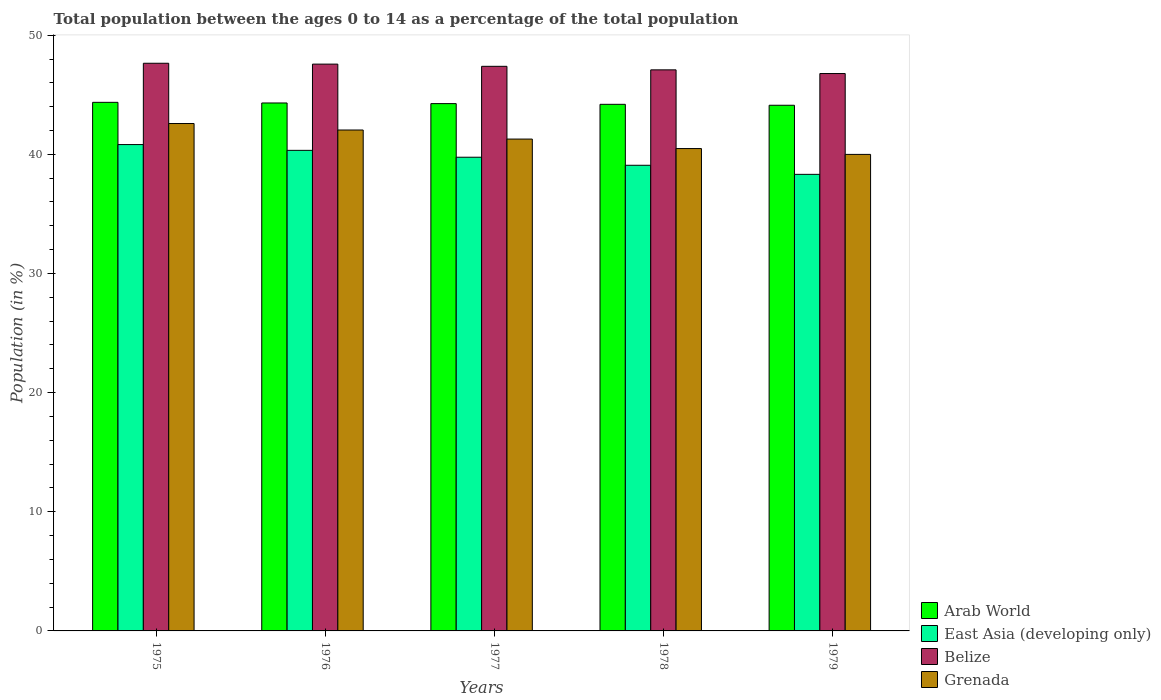Are the number of bars per tick equal to the number of legend labels?
Offer a very short reply. Yes. Are the number of bars on each tick of the X-axis equal?
Your response must be concise. Yes. How many bars are there on the 5th tick from the left?
Ensure brevity in your answer.  4. What is the label of the 1st group of bars from the left?
Offer a terse response. 1975. In how many cases, is the number of bars for a given year not equal to the number of legend labels?
Provide a short and direct response. 0. What is the percentage of the population ages 0 to 14 in Grenada in 1979?
Provide a succinct answer. 39.99. Across all years, what is the maximum percentage of the population ages 0 to 14 in East Asia (developing only)?
Give a very brief answer. 40.82. Across all years, what is the minimum percentage of the population ages 0 to 14 in Arab World?
Give a very brief answer. 44.12. In which year was the percentage of the population ages 0 to 14 in Belize maximum?
Your answer should be compact. 1975. In which year was the percentage of the population ages 0 to 14 in East Asia (developing only) minimum?
Make the answer very short. 1979. What is the total percentage of the population ages 0 to 14 in East Asia (developing only) in the graph?
Your answer should be very brief. 198.31. What is the difference between the percentage of the population ages 0 to 14 in Grenada in 1975 and that in 1979?
Your answer should be compact. 2.59. What is the difference between the percentage of the population ages 0 to 14 in East Asia (developing only) in 1975 and the percentage of the population ages 0 to 14 in Arab World in 1976?
Provide a succinct answer. -3.49. What is the average percentage of the population ages 0 to 14 in Grenada per year?
Provide a succinct answer. 41.28. In the year 1977, what is the difference between the percentage of the population ages 0 to 14 in Belize and percentage of the population ages 0 to 14 in East Asia (developing only)?
Provide a short and direct response. 7.63. In how many years, is the percentage of the population ages 0 to 14 in Belize greater than 46?
Provide a succinct answer. 5. What is the ratio of the percentage of the population ages 0 to 14 in Arab World in 1975 to that in 1977?
Your answer should be compact. 1. Is the difference between the percentage of the population ages 0 to 14 in Belize in 1976 and 1978 greater than the difference between the percentage of the population ages 0 to 14 in East Asia (developing only) in 1976 and 1978?
Your answer should be compact. No. What is the difference between the highest and the second highest percentage of the population ages 0 to 14 in Belize?
Your response must be concise. 0.07. What is the difference between the highest and the lowest percentage of the population ages 0 to 14 in East Asia (developing only)?
Make the answer very short. 2.5. What does the 2nd bar from the left in 1979 represents?
Your answer should be compact. East Asia (developing only). What does the 4th bar from the right in 1975 represents?
Provide a short and direct response. Arab World. Is it the case that in every year, the sum of the percentage of the population ages 0 to 14 in Belize and percentage of the population ages 0 to 14 in Grenada is greater than the percentage of the population ages 0 to 14 in East Asia (developing only)?
Keep it short and to the point. Yes. How many years are there in the graph?
Offer a very short reply. 5. What is the difference between two consecutive major ticks on the Y-axis?
Ensure brevity in your answer.  10. Are the values on the major ticks of Y-axis written in scientific E-notation?
Your answer should be very brief. No. Does the graph contain any zero values?
Keep it short and to the point. No. What is the title of the graph?
Give a very brief answer. Total population between the ages 0 to 14 as a percentage of the total population. What is the label or title of the X-axis?
Your answer should be very brief. Years. What is the label or title of the Y-axis?
Your answer should be very brief. Population (in %). What is the Population (in %) in Arab World in 1975?
Make the answer very short. 44.36. What is the Population (in %) of East Asia (developing only) in 1975?
Offer a terse response. 40.82. What is the Population (in %) of Belize in 1975?
Your answer should be very brief. 47.64. What is the Population (in %) of Grenada in 1975?
Your answer should be compact. 42.59. What is the Population (in %) in Arab World in 1976?
Make the answer very short. 44.31. What is the Population (in %) in East Asia (developing only) in 1976?
Ensure brevity in your answer.  40.33. What is the Population (in %) in Belize in 1976?
Provide a succinct answer. 47.57. What is the Population (in %) of Grenada in 1976?
Provide a short and direct response. 42.04. What is the Population (in %) in Arab World in 1977?
Your answer should be very brief. 44.26. What is the Population (in %) of East Asia (developing only) in 1977?
Your answer should be compact. 39.76. What is the Population (in %) in Belize in 1977?
Your answer should be compact. 47.39. What is the Population (in %) of Grenada in 1977?
Your response must be concise. 41.28. What is the Population (in %) of Arab World in 1978?
Keep it short and to the point. 44.2. What is the Population (in %) in East Asia (developing only) in 1978?
Give a very brief answer. 39.08. What is the Population (in %) of Belize in 1978?
Offer a terse response. 47.09. What is the Population (in %) in Grenada in 1978?
Give a very brief answer. 40.48. What is the Population (in %) in Arab World in 1979?
Offer a terse response. 44.12. What is the Population (in %) of East Asia (developing only) in 1979?
Offer a very short reply. 38.32. What is the Population (in %) of Belize in 1979?
Your answer should be compact. 46.78. What is the Population (in %) of Grenada in 1979?
Your answer should be compact. 39.99. Across all years, what is the maximum Population (in %) of Arab World?
Offer a very short reply. 44.36. Across all years, what is the maximum Population (in %) of East Asia (developing only)?
Give a very brief answer. 40.82. Across all years, what is the maximum Population (in %) of Belize?
Keep it short and to the point. 47.64. Across all years, what is the maximum Population (in %) of Grenada?
Make the answer very short. 42.59. Across all years, what is the minimum Population (in %) of Arab World?
Give a very brief answer. 44.12. Across all years, what is the minimum Population (in %) in East Asia (developing only)?
Offer a terse response. 38.32. Across all years, what is the minimum Population (in %) of Belize?
Provide a short and direct response. 46.78. Across all years, what is the minimum Population (in %) of Grenada?
Provide a short and direct response. 39.99. What is the total Population (in %) of Arab World in the graph?
Your answer should be very brief. 221.24. What is the total Population (in %) of East Asia (developing only) in the graph?
Your answer should be very brief. 198.31. What is the total Population (in %) of Belize in the graph?
Provide a short and direct response. 236.47. What is the total Population (in %) in Grenada in the graph?
Offer a terse response. 206.39. What is the difference between the Population (in %) of Arab World in 1975 and that in 1976?
Offer a terse response. 0.05. What is the difference between the Population (in %) of East Asia (developing only) in 1975 and that in 1976?
Your response must be concise. 0.48. What is the difference between the Population (in %) of Belize in 1975 and that in 1976?
Your response must be concise. 0.07. What is the difference between the Population (in %) in Grenada in 1975 and that in 1976?
Offer a terse response. 0.55. What is the difference between the Population (in %) in Arab World in 1975 and that in 1977?
Offer a terse response. 0.11. What is the difference between the Population (in %) of East Asia (developing only) in 1975 and that in 1977?
Provide a succinct answer. 1.06. What is the difference between the Population (in %) in Belize in 1975 and that in 1977?
Give a very brief answer. 0.26. What is the difference between the Population (in %) of Grenada in 1975 and that in 1977?
Your answer should be compact. 1.31. What is the difference between the Population (in %) in Arab World in 1975 and that in 1978?
Provide a succinct answer. 0.17. What is the difference between the Population (in %) of East Asia (developing only) in 1975 and that in 1978?
Offer a very short reply. 1.74. What is the difference between the Population (in %) of Belize in 1975 and that in 1978?
Provide a short and direct response. 0.55. What is the difference between the Population (in %) in Grenada in 1975 and that in 1978?
Provide a short and direct response. 2.1. What is the difference between the Population (in %) of Arab World in 1975 and that in 1979?
Give a very brief answer. 0.24. What is the difference between the Population (in %) of East Asia (developing only) in 1975 and that in 1979?
Your answer should be compact. 2.5. What is the difference between the Population (in %) of Belize in 1975 and that in 1979?
Offer a very short reply. 0.86. What is the difference between the Population (in %) of Grenada in 1975 and that in 1979?
Provide a succinct answer. 2.59. What is the difference between the Population (in %) of Arab World in 1976 and that in 1977?
Your answer should be very brief. 0.05. What is the difference between the Population (in %) of East Asia (developing only) in 1976 and that in 1977?
Your answer should be very brief. 0.58. What is the difference between the Population (in %) in Belize in 1976 and that in 1977?
Ensure brevity in your answer.  0.18. What is the difference between the Population (in %) in Grenada in 1976 and that in 1977?
Offer a terse response. 0.76. What is the difference between the Population (in %) in Arab World in 1976 and that in 1978?
Keep it short and to the point. 0.11. What is the difference between the Population (in %) of East Asia (developing only) in 1976 and that in 1978?
Your answer should be compact. 1.25. What is the difference between the Population (in %) of Belize in 1976 and that in 1978?
Give a very brief answer. 0.48. What is the difference between the Population (in %) in Grenada in 1976 and that in 1978?
Provide a succinct answer. 1.56. What is the difference between the Population (in %) in Arab World in 1976 and that in 1979?
Your response must be concise. 0.19. What is the difference between the Population (in %) of East Asia (developing only) in 1976 and that in 1979?
Offer a very short reply. 2.01. What is the difference between the Population (in %) in Belize in 1976 and that in 1979?
Give a very brief answer. 0.79. What is the difference between the Population (in %) of Grenada in 1976 and that in 1979?
Provide a succinct answer. 2.05. What is the difference between the Population (in %) in Arab World in 1977 and that in 1978?
Keep it short and to the point. 0.06. What is the difference between the Population (in %) in East Asia (developing only) in 1977 and that in 1978?
Give a very brief answer. 0.68. What is the difference between the Population (in %) in Belize in 1977 and that in 1978?
Make the answer very short. 0.3. What is the difference between the Population (in %) in Grenada in 1977 and that in 1978?
Your answer should be very brief. 0.8. What is the difference between the Population (in %) in Arab World in 1977 and that in 1979?
Ensure brevity in your answer.  0.14. What is the difference between the Population (in %) in East Asia (developing only) in 1977 and that in 1979?
Give a very brief answer. 1.44. What is the difference between the Population (in %) in Belize in 1977 and that in 1979?
Your answer should be very brief. 0.61. What is the difference between the Population (in %) in Grenada in 1977 and that in 1979?
Offer a terse response. 1.29. What is the difference between the Population (in %) in Arab World in 1978 and that in 1979?
Keep it short and to the point. 0.08. What is the difference between the Population (in %) of East Asia (developing only) in 1978 and that in 1979?
Provide a succinct answer. 0.76. What is the difference between the Population (in %) in Belize in 1978 and that in 1979?
Provide a short and direct response. 0.31. What is the difference between the Population (in %) of Grenada in 1978 and that in 1979?
Provide a short and direct response. 0.49. What is the difference between the Population (in %) in Arab World in 1975 and the Population (in %) in East Asia (developing only) in 1976?
Your answer should be compact. 4.03. What is the difference between the Population (in %) of Arab World in 1975 and the Population (in %) of Belize in 1976?
Offer a very short reply. -3.21. What is the difference between the Population (in %) in Arab World in 1975 and the Population (in %) in Grenada in 1976?
Give a very brief answer. 2.32. What is the difference between the Population (in %) of East Asia (developing only) in 1975 and the Population (in %) of Belize in 1976?
Make the answer very short. -6.75. What is the difference between the Population (in %) in East Asia (developing only) in 1975 and the Population (in %) in Grenada in 1976?
Ensure brevity in your answer.  -1.22. What is the difference between the Population (in %) in Belize in 1975 and the Population (in %) in Grenada in 1976?
Your response must be concise. 5.6. What is the difference between the Population (in %) in Arab World in 1975 and the Population (in %) in East Asia (developing only) in 1977?
Your response must be concise. 4.61. What is the difference between the Population (in %) of Arab World in 1975 and the Population (in %) of Belize in 1977?
Offer a very short reply. -3.02. What is the difference between the Population (in %) in Arab World in 1975 and the Population (in %) in Grenada in 1977?
Offer a terse response. 3.08. What is the difference between the Population (in %) of East Asia (developing only) in 1975 and the Population (in %) of Belize in 1977?
Your response must be concise. -6.57. What is the difference between the Population (in %) in East Asia (developing only) in 1975 and the Population (in %) in Grenada in 1977?
Your answer should be very brief. -0.46. What is the difference between the Population (in %) in Belize in 1975 and the Population (in %) in Grenada in 1977?
Make the answer very short. 6.36. What is the difference between the Population (in %) of Arab World in 1975 and the Population (in %) of East Asia (developing only) in 1978?
Your answer should be compact. 5.28. What is the difference between the Population (in %) of Arab World in 1975 and the Population (in %) of Belize in 1978?
Provide a succinct answer. -2.73. What is the difference between the Population (in %) of Arab World in 1975 and the Population (in %) of Grenada in 1978?
Your answer should be very brief. 3.88. What is the difference between the Population (in %) in East Asia (developing only) in 1975 and the Population (in %) in Belize in 1978?
Offer a terse response. -6.27. What is the difference between the Population (in %) of East Asia (developing only) in 1975 and the Population (in %) of Grenada in 1978?
Offer a terse response. 0.34. What is the difference between the Population (in %) in Belize in 1975 and the Population (in %) in Grenada in 1978?
Your answer should be very brief. 7.16. What is the difference between the Population (in %) of Arab World in 1975 and the Population (in %) of East Asia (developing only) in 1979?
Your response must be concise. 6.04. What is the difference between the Population (in %) in Arab World in 1975 and the Population (in %) in Belize in 1979?
Your answer should be very brief. -2.42. What is the difference between the Population (in %) of Arab World in 1975 and the Population (in %) of Grenada in 1979?
Provide a succinct answer. 4.37. What is the difference between the Population (in %) of East Asia (developing only) in 1975 and the Population (in %) of Belize in 1979?
Your answer should be very brief. -5.96. What is the difference between the Population (in %) of East Asia (developing only) in 1975 and the Population (in %) of Grenada in 1979?
Your answer should be compact. 0.83. What is the difference between the Population (in %) in Belize in 1975 and the Population (in %) in Grenada in 1979?
Offer a terse response. 7.65. What is the difference between the Population (in %) in Arab World in 1976 and the Population (in %) in East Asia (developing only) in 1977?
Your answer should be very brief. 4.55. What is the difference between the Population (in %) in Arab World in 1976 and the Population (in %) in Belize in 1977?
Your answer should be compact. -3.08. What is the difference between the Population (in %) in Arab World in 1976 and the Population (in %) in Grenada in 1977?
Give a very brief answer. 3.03. What is the difference between the Population (in %) of East Asia (developing only) in 1976 and the Population (in %) of Belize in 1977?
Offer a very short reply. -7.05. What is the difference between the Population (in %) of East Asia (developing only) in 1976 and the Population (in %) of Grenada in 1977?
Your response must be concise. -0.95. What is the difference between the Population (in %) in Belize in 1976 and the Population (in %) in Grenada in 1977?
Offer a very short reply. 6.29. What is the difference between the Population (in %) in Arab World in 1976 and the Population (in %) in East Asia (developing only) in 1978?
Offer a terse response. 5.23. What is the difference between the Population (in %) in Arab World in 1976 and the Population (in %) in Belize in 1978?
Your response must be concise. -2.78. What is the difference between the Population (in %) in Arab World in 1976 and the Population (in %) in Grenada in 1978?
Ensure brevity in your answer.  3.83. What is the difference between the Population (in %) in East Asia (developing only) in 1976 and the Population (in %) in Belize in 1978?
Offer a terse response. -6.76. What is the difference between the Population (in %) of East Asia (developing only) in 1976 and the Population (in %) of Grenada in 1978?
Ensure brevity in your answer.  -0.15. What is the difference between the Population (in %) in Belize in 1976 and the Population (in %) in Grenada in 1978?
Ensure brevity in your answer.  7.09. What is the difference between the Population (in %) of Arab World in 1976 and the Population (in %) of East Asia (developing only) in 1979?
Ensure brevity in your answer.  5.99. What is the difference between the Population (in %) in Arab World in 1976 and the Population (in %) in Belize in 1979?
Ensure brevity in your answer.  -2.47. What is the difference between the Population (in %) of Arab World in 1976 and the Population (in %) of Grenada in 1979?
Your response must be concise. 4.32. What is the difference between the Population (in %) in East Asia (developing only) in 1976 and the Population (in %) in Belize in 1979?
Your answer should be very brief. -6.45. What is the difference between the Population (in %) of East Asia (developing only) in 1976 and the Population (in %) of Grenada in 1979?
Provide a short and direct response. 0.34. What is the difference between the Population (in %) in Belize in 1976 and the Population (in %) in Grenada in 1979?
Keep it short and to the point. 7.58. What is the difference between the Population (in %) of Arab World in 1977 and the Population (in %) of East Asia (developing only) in 1978?
Offer a very short reply. 5.17. What is the difference between the Population (in %) of Arab World in 1977 and the Population (in %) of Belize in 1978?
Your answer should be very brief. -2.83. What is the difference between the Population (in %) of Arab World in 1977 and the Population (in %) of Grenada in 1978?
Ensure brevity in your answer.  3.77. What is the difference between the Population (in %) in East Asia (developing only) in 1977 and the Population (in %) in Belize in 1978?
Give a very brief answer. -7.33. What is the difference between the Population (in %) of East Asia (developing only) in 1977 and the Population (in %) of Grenada in 1978?
Ensure brevity in your answer.  -0.73. What is the difference between the Population (in %) in Belize in 1977 and the Population (in %) in Grenada in 1978?
Offer a very short reply. 6.9. What is the difference between the Population (in %) of Arab World in 1977 and the Population (in %) of East Asia (developing only) in 1979?
Your answer should be compact. 5.94. What is the difference between the Population (in %) of Arab World in 1977 and the Population (in %) of Belize in 1979?
Provide a succinct answer. -2.53. What is the difference between the Population (in %) in Arab World in 1977 and the Population (in %) in Grenada in 1979?
Your response must be concise. 4.26. What is the difference between the Population (in %) of East Asia (developing only) in 1977 and the Population (in %) of Belize in 1979?
Provide a succinct answer. -7.02. What is the difference between the Population (in %) of East Asia (developing only) in 1977 and the Population (in %) of Grenada in 1979?
Provide a short and direct response. -0.24. What is the difference between the Population (in %) in Belize in 1977 and the Population (in %) in Grenada in 1979?
Give a very brief answer. 7.39. What is the difference between the Population (in %) of Arab World in 1978 and the Population (in %) of East Asia (developing only) in 1979?
Offer a very short reply. 5.88. What is the difference between the Population (in %) of Arab World in 1978 and the Population (in %) of Belize in 1979?
Provide a succinct answer. -2.58. What is the difference between the Population (in %) of Arab World in 1978 and the Population (in %) of Grenada in 1979?
Offer a terse response. 4.2. What is the difference between the Population (in %) of East Asia (developing only) in 1978 and the Population (in %) of Belize in 1979?
Provide a succinct answer. -7.7. What is the difference between the Population (in %) of East Asia (developing only) in 1978 and the Population (in %) of Grenada in 1979?
Offer a very short reply. -0.91. What is the difference between the Population (in %) in Belize in 1978 and the Population (in %) in Grenada in 1979?
Offer a terse response. 7.1. What is the average Population (in %) in Arab World per year?
Provide a succinct answer. 44.25. What is the average Population (in %) in East Asia (developing only) per year?
Ensure brevity in your answer.  39.66. What is the average Population (in %) in Belize per year?
Offer a terse response. 47.29. What is the average Population (in %) of Grenada per year?
Keep it short and to the point. 41.28. In the year 1975, what is the difference between the Population (in %) in Arab World and Population (in %) in East Asia (developing only)?
Offer a terse response. 3.54. In the year 1975, what is the difference between the Population (in %) in Arab World and Population (in %) in Belize?
Offer a terse response. -3.28. In the year 1975, what is the difference between the Population (in %) of Arab World and Population (in %) of Grenada?
Provide a short and direct response. 1.78. In the year 1975, what is the difference between the Population (in %) of East Asia (developing only) and Population (in %) of Belize?
Provide a succinct answer. -6.82. In the year 1975, what is the difference between the Population (in %) in East Asia (developing only) and Population (in %) in Grenada?
Offer a terse response. -1.77. In the year 1975, what is the difference between the Population (in %) in Belize and Population (in %) in Grenada?
Your answer should be compact. 5.06. In the year 1976, what is the difference between the Population (in %) of Arab World and Population (in %) of East Asia (developing only)?
Make the answer very short. 3.98. In the year 1976, what is the difference between the Population (in %) of Arab World and Population (in %) of Belize?
Provide a succinct answer. -3.26. In the year 1976, what is the difference between the Population (in %) of Arab World and Population (in %) of Grenada?
Ensure brevity in your answer.  2.27. In the year 1976, what is the difference between the Population (in %) in East Asia (developing only) and Population (in %) in Belize?
Ensure brevity in your answer.  -7.24. In the year 1976, what is the difference between the Population (in %) of East Asia (developing only) and Population (in %) of Grenada?
Give a very brief answer. -1.71. In the year 1976, what is the difference between the Population (in %) of Belize and Population (in %) of Grenada?
Keep it short and to the point. 5.53. In the year 1977, what is the difference between the Population (in %) of Arab World and Population (in %) of East Asia (developing only)?
Ensure brevity in your answer.  4.5. In the year 1977, what is the difference between the Population (in %) of Arab World and Population (in %) of Belize?
Give a very brief answer. -3.13. In the year 1977, what is the difference between the Population (in %) in Arab World and Population (in %) in Grenada?
Your answer should be very brief. 2.97. In the year 1977, what is the difference between the Population (in %) of East Asia (developing only) and Population (in %) of Belize?
Your response must be concise. -7.63. In the year 1977, what is the difference between the Population (in %) in East Asia (developing only) and Population (in %) in Grenada?
Offer a terse response. -1.52. In the year 1977, what is the difference between the Population (in %) in Belize and Population (in %) in Grenada?
Provide a succinct answer. 6.11. In the year 1978, what is the difference between the Population (in %) of Arab World and Population (in %) of East Asia (developing only)?
Provide a short and direct response. 5.12. In the year 1978, what is the difference between the Population (in %) of Arab World and Population (in %) of Belize?
Keep it short and to the point. -2.89. In the year 1978, what is the difference between the Population (in %) in Arab World and Population (in %) in Grenada?
Ensure brevity in your answer.  3.71. In the year 1978, what is the difference between the Population (in %) in East Asia (developing only) and Population (in %) in Belize?
Provide a succinct answer. -8.01. In the year 1978, what is the difference between the Population (in %) in East Asia (developing only) and Population (in %) in Grenada?
Keep it short and to the point. -1.4. In the year 1978, what is the difference between the Population (in %) in Belize and Population (in %) in Grenada?
Make the answer very short. 6.61. In the year 1979, what is the difference between the Population (in %) in Arab World and Population (in %) in East Asia (developing only)?
Offer a terse response. 5.8. In the year 1979, what is the difference between the Population (in %) of Arab World and Population (in %) of Belize?
Ensure brevity in your answer.  -2.66. In the year 1979, what is the difference between the Population (in %) in Arab World and Population (in %) in Grenada?
Make the answer very short. 4.12. In the year 1979, what is the difference between the Population (in %) of East Asia (developing only) and Population (in %) of Belize?
Your answer should be very brief. -8.46. In the year 1979, what is the difference between the Population (in %) in East Asia (developing only) and Population (in %) in Grenada?
Offer a terse response. -1.67. In the year 1979, what is the difference between the Population (in %) in Belize and Population (in %) in Grenada?
Your answer should be compact. 6.79. What is the ratio of the Population (in %) of Arab World in 1975 to that in 1976?
Give a very brief answer. 1. What is the ratio of the Population (in %) in East Asia (developing only) in 1975 to that in 1976?
Ensure brevity in your answer.  1.01. What is the ratio of the Population (in %) in East Asia (developing only) in 1975 to that in 1977?
Your response must be concise. 1.03. What is the ratio of the Population (in %) in Belize in 1975 to that in 1977?
Your answer should be compact. 1.01. What is the ratio of the Population (in %) in Grenada in 1975 to that in 1977?
Make the answer very short. 1.03. What is the ratio of the Population (in %) of Arab World in 1975 to that in 1978?
Your answer should be very brief. 1. What is the ratio of the Population (in %) of East Asia (developing only) in 1975 to that in 1978?
Keep it short and to the point. 1.04. What is the ratio of the Population (in %) of Belize in 1975 to that in 1978?
Offer a terse response. 1.01. What is the ratio of the Population (in %) of Grenada in 1975 to that in 1978?
Give a very brief answer. 1.05. What is the ratio of the Population (in %) in East Asia (developing only) in 1975 to that in 1979?
Your response must be concise. 1.07. What is the ratio of the Population (in %) in Belize in 1975 to that in 1979?
Your answer should be very brief. 1.02. What is the ratio of the Population (in %) of Grenada in 1975 to that in 1979?
Offer a very short reply. 1.06. What is the ratio of the Population (in %) in Arab World in 1976 to that in 1977?
Ensure brevity in your answer.  1. What is the ratio of the Population (in %) of East Asia (developing only) in 1976 to that in 1977?
Keep it short and to the point. 1.01. What is the ratio of the Population (in %) in Belize in 1976 to that in 1977?
Make the answer very short. 1. What is the ratio of the Population (in %) of Grenada in 1976 to that in 1977?
Offer a very short reply. 1.02. What is the ratio of the Population (in %) of East Asia (developing only) in 1976 to that in 1978?
Provide a succinct answer. 1.03. What is the ratio of the Population (in %) of Belize in 1976 to that in 1978?
Keep it short and to the point. 1.01. What is the ratio of the Population (in %) of Arab World in 1976 to that in 1979?
Ensure brevity in your answer.  1. What is the ratio of the Population (in %) of East Asia (developing only) in 1976 to that in 1979?
Provide a succinct answer. 1.05. What is the ratio of the Population (in %) in Belize in 1976 to that in 1979?
Your answer should be compact. 1.02. What is the ratio of the Population (in %) of Grenada in 1976 to that in 1979?
Your response must be concise. 1.05. What is the ratio of the Population (in %) in East Asia (developing only) in 1977 to that in 1978?
Give a very brief answer. 1.02. What is the ratio of the Population (in %) in Belize in 1977 to that in 1978?
Give a very brief answer. 1.01. What is the ratio of the Population (in %) in Grenada in 1977 to that in 1978?
Your answer should be compact. 1.02. What is the ratio of the Population (in %) of Arab World in 1977 to that in 1979?
Ensure brevity in your answer.  1. What is the ratio of the Population (in %) of East Asia (developing only) in 1977 to that in 1979?
Provide a short and direct response. 1.04. What is the ratio of the Population (in %) of Belize in 1977 to that in 1979?
Ensure brevity in your answer.  1.01. What is the ratio of the Population (in %) in Grenada in 1977 to that in 1979?
Offer a very short reply. 1.03. What is the ratio of the Population (in %) of Arab World in 1978 to that in 1979?
Offer a terse response. 1. What is the ratio of the Population (in %) of East Asia (developing only) in 1978 to that in 1979?
Offer a very short reply. 1.02. What is the ratio of the Population (in %) of Belize in 1978 to that in 1979?
Ensure brevity in your answer.  1.01. What is the ratio of the Population (in %) in Grenada in 1978 to that in 1979?
Your response must be concise. 1.01. What is the difference between the highest and the second highest Population (in %) of Arab World?
Ensure brevity in your answer.  0.05. What is the difference between the highest and the second highest Population (in %) of East Asia (developing only)?
Provide a succinct answer. 0.48. What is the difference between the highest and the second highest Population (in %) in Belize?
Provide a succinct answer. 0.07. What is the difference between the highest and the second highest Population (in %) of Grenada?
Offer a terse response. 0.55. What is the difference between the highest and the lowest Population (in %) in Arab World?
Ensure brevity in your answer.  0.24. What is the difference between the highest and the lowest Population (in %) in East Asia (developing only)?
Give a very brief answer. 2.5. What is the difference between the highest and the lowest Population (in %) in Belize?
Offer a very short reply. 0.86. What is the difference between the highest and the lowest Population (in %) in Grenada?
Ensure brevity in your answer.  2.59. 